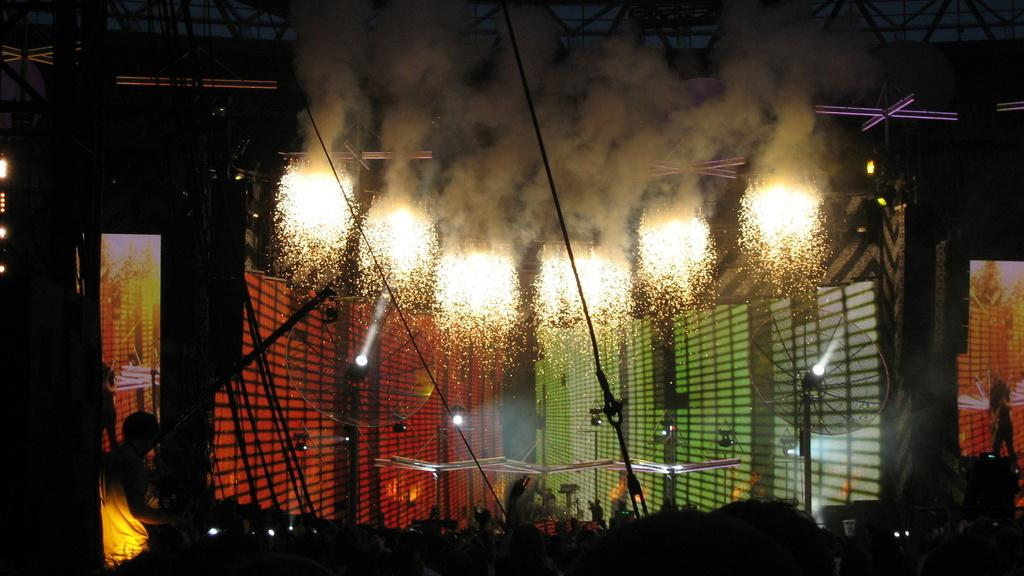What can be seen in the image that produces light? There are lights in the image. What is happening in the sky in the image? Fireworks are visible in the image. Can you describe the person in the image? There is a person on the left side of the image. What is present in the background of the image? There are screens in the background of the image. What type of mark does the zebra make on the screens in the image? There is no zebra present in the image, so it cannot make any marks on the screens. Can you hear the person whistling in the image? The image is silent, so we cannot hear any sounds, including whistling. 